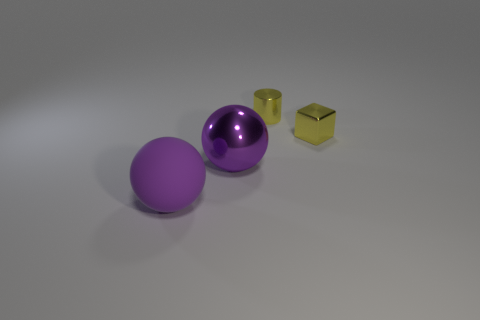Does the purple matte thing have the same shape as the large purple metal object?
Offer a very short reply. Yes. How many things are in front of the yellow cylinder and to the right of the large purple matte thing?
Make the answer very short. 2. Is the size of the yellow thing to the right of the shiny cylinder the same as the sphere on the right side of the large purple rubber object?
Your answer should be compact. No. What is the size of the thing in front of the big metallic sphere?
Offer a very short reply. Large. How many objects are large purple spheres right of the big purple matte thing or big purple spheres in front of the big purple metal object?
Your response must be concise. 2. Are there the same number of purple metal balls that are behind the shiny block and spheres behind the purple rubber sphere?
Ensure brevity in your answer.  No. Are there more large purple balls to the left of the small metal cube than big red cylinders?
Keep it short and to the point. Yes. How many things are either purple spheres on the right side of the purple matte sphere or tiny yellow metallic things?
Provide a short and direct response. 3. What number of yellow cubes have the same material as the yellow cylinder?
Ensure brevity in your answer.  1. There is a metal object that is the same color as the shiny cube; what shape is it?
Offer a terse response. Cylinder. 